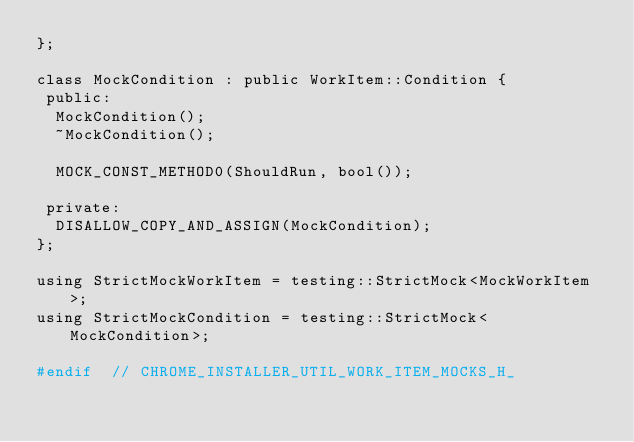<code> <loc_0><loc_0><loc_500><loc_500><_C_>};

class MockCondition : public WorkItem::Condition {
 public:
  MockCondition();
  ~MockCondition();

  MOCK_CONST_METHOD0(ShouldRun, bool());

 private:
  DISALLOW_COPY_AND_ASSIGN(MockCondition);
};

using StrictMockWorkItem = testing::StrictMock<MockWorkItem>;
using StrictMockCondition = testing::StrictMock<MockCondition>;

#endif  // CHROME_INSTALLER_UTIL_WORK_ITEM_MOCKS_H_
</code> 